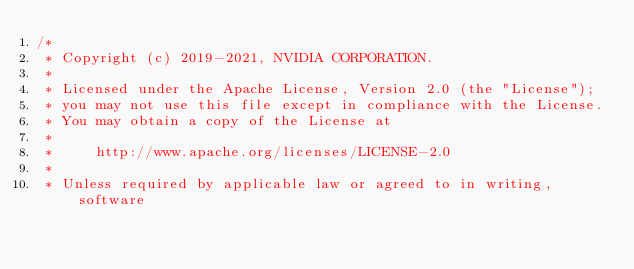Convert code to text. <code><loc_0><loc_0><loc_500><loc_500><_Cuda_>/*
 * Copyright (c) 2019-2021, NVIDIA CORPORATION.
 *
 * Licensed under the Apache License, Version 2.0 (the "License");
 * you may not use this file except in compliance with the License.
 * You may obtain a copy of the License at
 *
 *     http://www.apache.org/licenses/LICENSE-2.0
 *
 * Unless required by applicable law or agreed to in writing, software</code> 